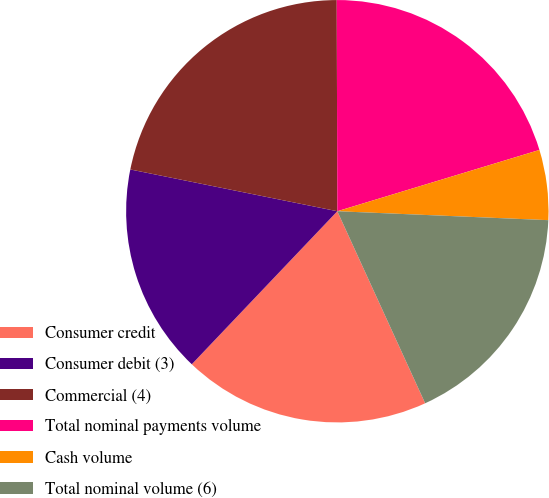<chart> <loc_0><loc_0><loc_500><loc_500><pie_chart><fcel>Consumer credit<fcel>Consumer debit (3)<fcel>Commercial (4)<fcel>Total nominal payments volume<fcel>Cash volume<fcel>Total nominal volume (6)<nl><fcel>18.93%<fcel>16.07%<fcel>21.79%<fcel>20.36%<fcel>5.36%<fcel>17.5%<nl></chart> 